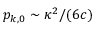<formula> <loc_0><loc_0><loc_500><loc_500>p _ { k , 0 } \sim \kappa ^ { 2 } / ( 6 c )</formula> 